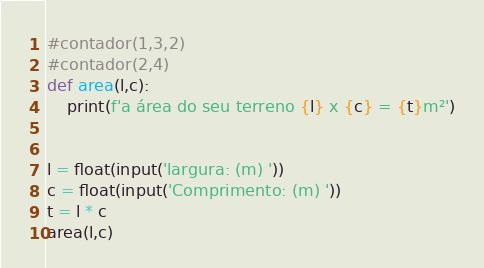Convert code to text. <code><loc_0><loc_0><loc_500><loc_500><_Python_>#contador(1,3,2)
#contador(2,4)
def area(l,c):
    print(f'a área do seu terreno {l} x {c} = {t}m²')


l = float(input('largura: (m) '))
c = float(input('Comprimento: (m) '))
t = l * c
area(l,c) </code> 